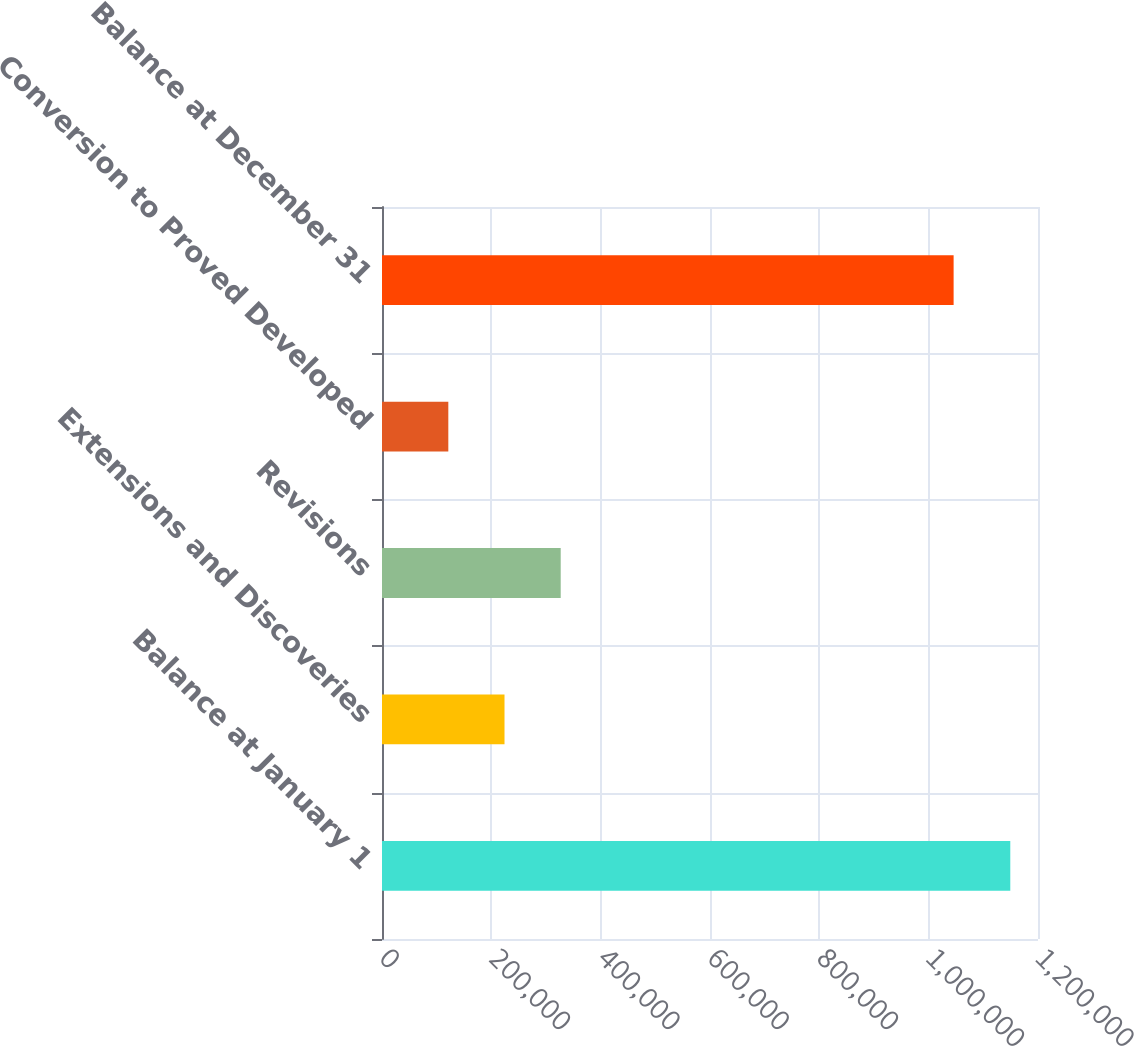<chart> <loc_0><loc_0><loc_500><loc_500><bar_chart><fcel>Balance at January 1<fcel>Extensions and Discoveries<fcel>Revisions<fcel>Conversion to Proved Developed<fcel>Balance at December 31<nl><fcel>1.14931e+06<fcel>224106<fcel>326907<fcel>121306<fcel>1.04564e+06<nl></chart> 